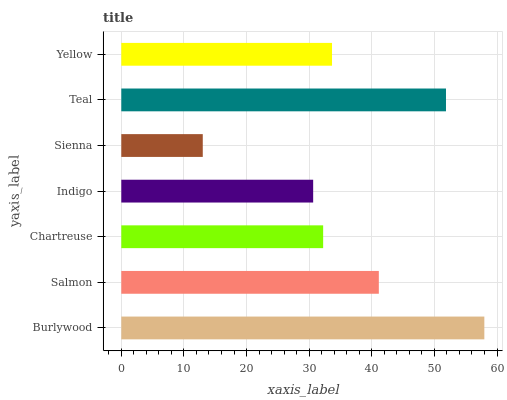Is Sienna the minimum?
Answer yes or no. Yes. Is Burlywood the maximum?
Answer yes or no. Yes. Is Salmon the minimum?
Answer yes or no. No. Is Salmon the maximum?
Answer yes or no. No. Is Burlywood greater than Salmon?
Answer yes or no. Yes. Is Salmon less than Burlywood?
Answer yes or no. Yes. Is Salmon greater than Burlywood?
Answer yes or no. No. Is Burlywood less than Salmon?
Answer yes or no. No. Is Yellow the high median?
Answer yes or no. Yes. Is Yellow the low median?
Answer yes or no. Yes. Is Salmon the high median?
Answer yes or no. No. Is Salmon the low median?
Answer yes or no. No. 